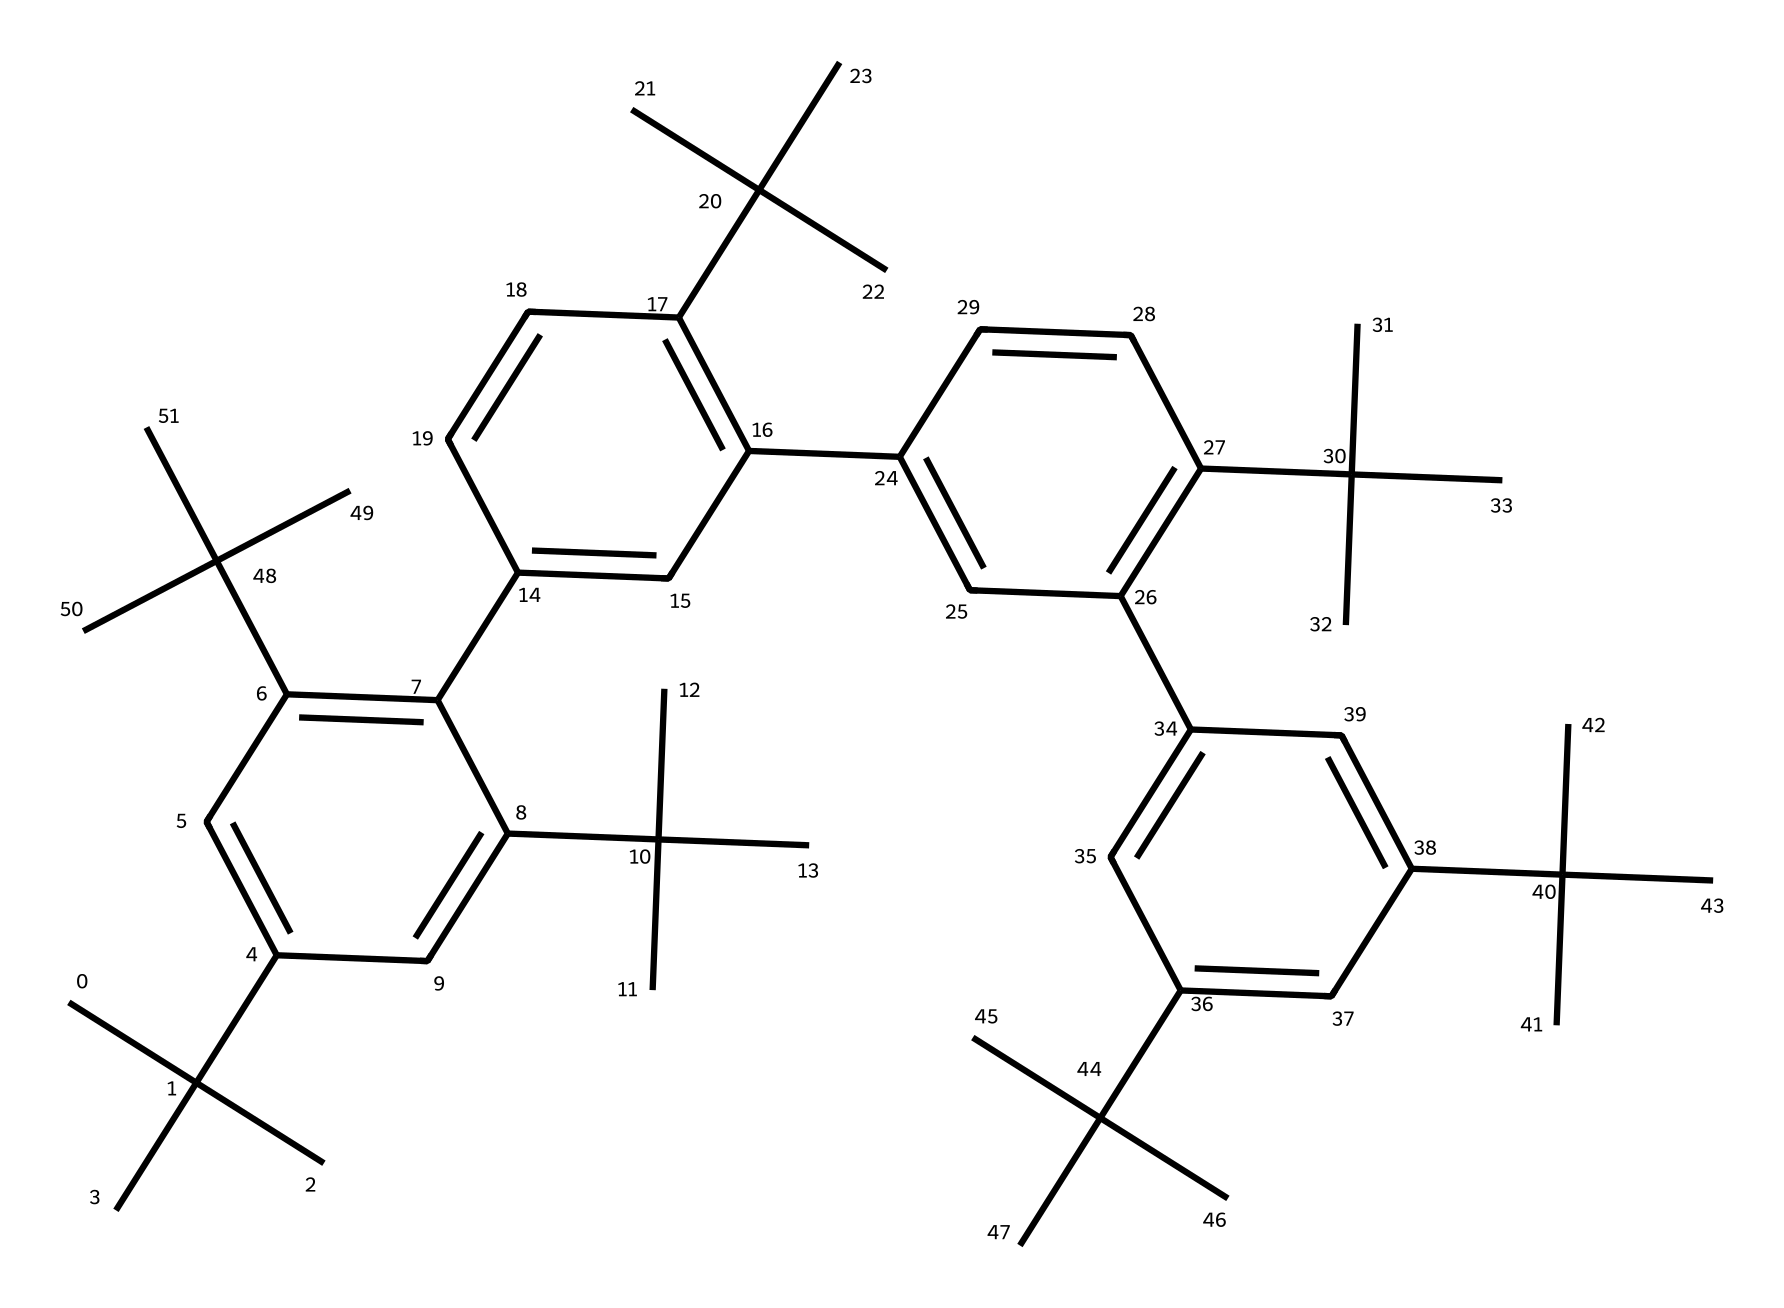What is the main chemical class of this compound? The SMILES representation features multiple aromatic rings and a complex branched structure, indicating it belongs to the class of polymers, particularly those that are used for radiation resistance.
Answer: polymer How many aromatic rings are present in the structure? By analyzing the SMILES, several occurrences of "C=C" suggest the presence of aromatic systems. Counting the distinct occurrences reveals a total of four aromatic rings in the structure.
Answer: four What type of bonds are predominantly found in this chemical structure? The SMILES indicates a combination of single and double bonds. The presence of multiple "C=C" pairs indicates that double bonds are prevalent in the structure, particularly within the aromatic portions.
Answer: double bonds Is this compound likely to be hydrophobic or hydrophilic? Given the large number of carbon atoms and the structure's complexity with minimal polar functional groups, this compound is likely hydrophobic, which is common in many polymers used in electronics protection.
Answer: hydrophobic How does the branched structure impact its radiation resistance? A branched polymer structure increases molecular weight and entanglement, providing enhanced mechanical strength and stability under radiation, which mitigates damage to the electronic components.
Answer: enhances stability 